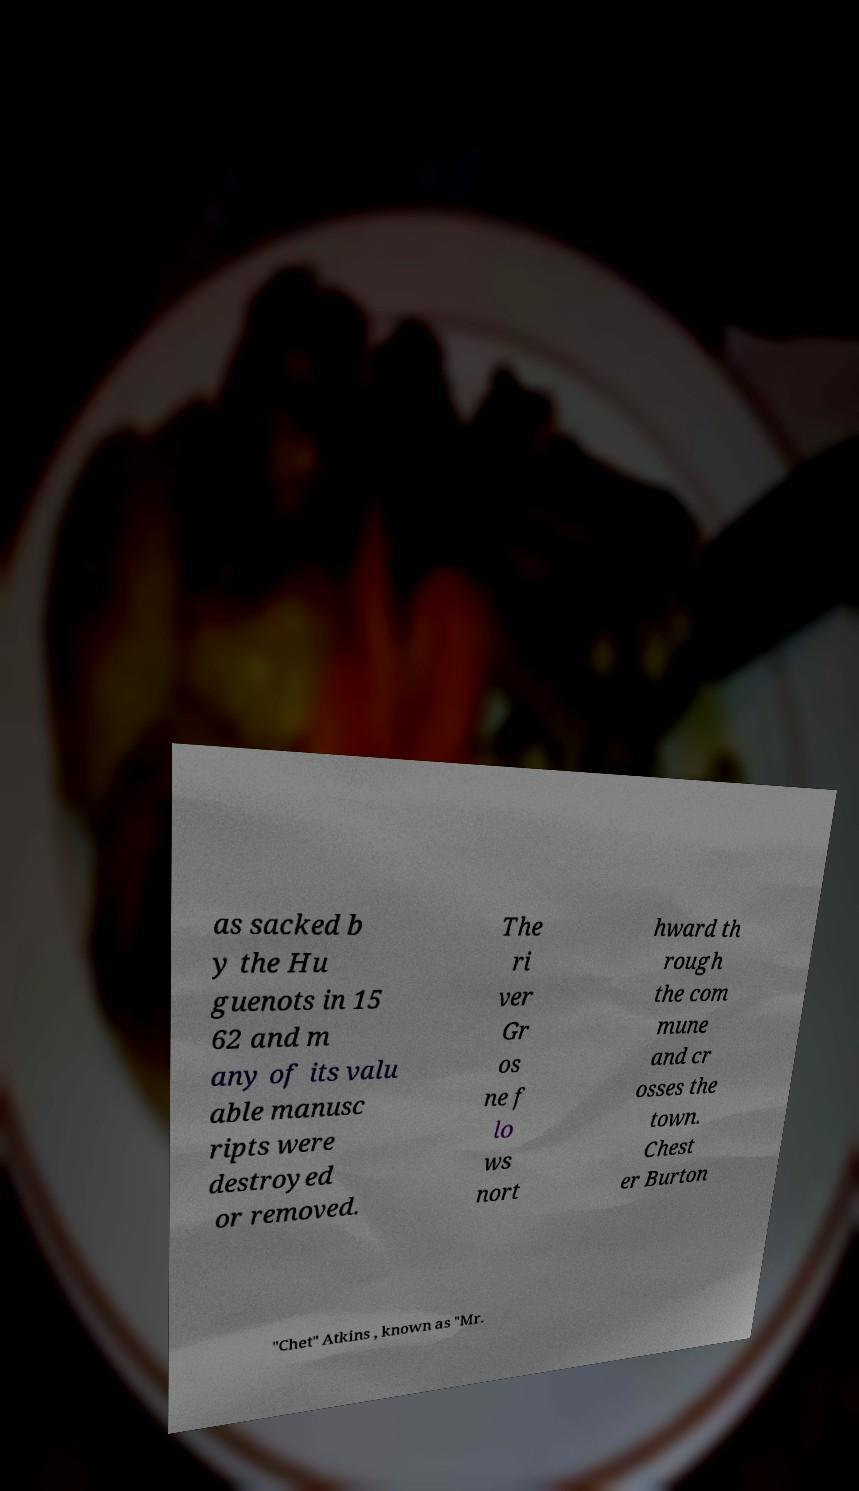Can you read and provide the text displayed in the image?This photo seems to have some interesting text. Can you extract and type it out for me? as sacked b y the Hu guenots in 15 62 and m any of its valu able manusc ripts were destroyed or removed. The ri ver Gr os ne f lo ws nort hward th rough the com mune and cr osses the town. Chest er Burton "Chet" Atkins , known as "Mr. 